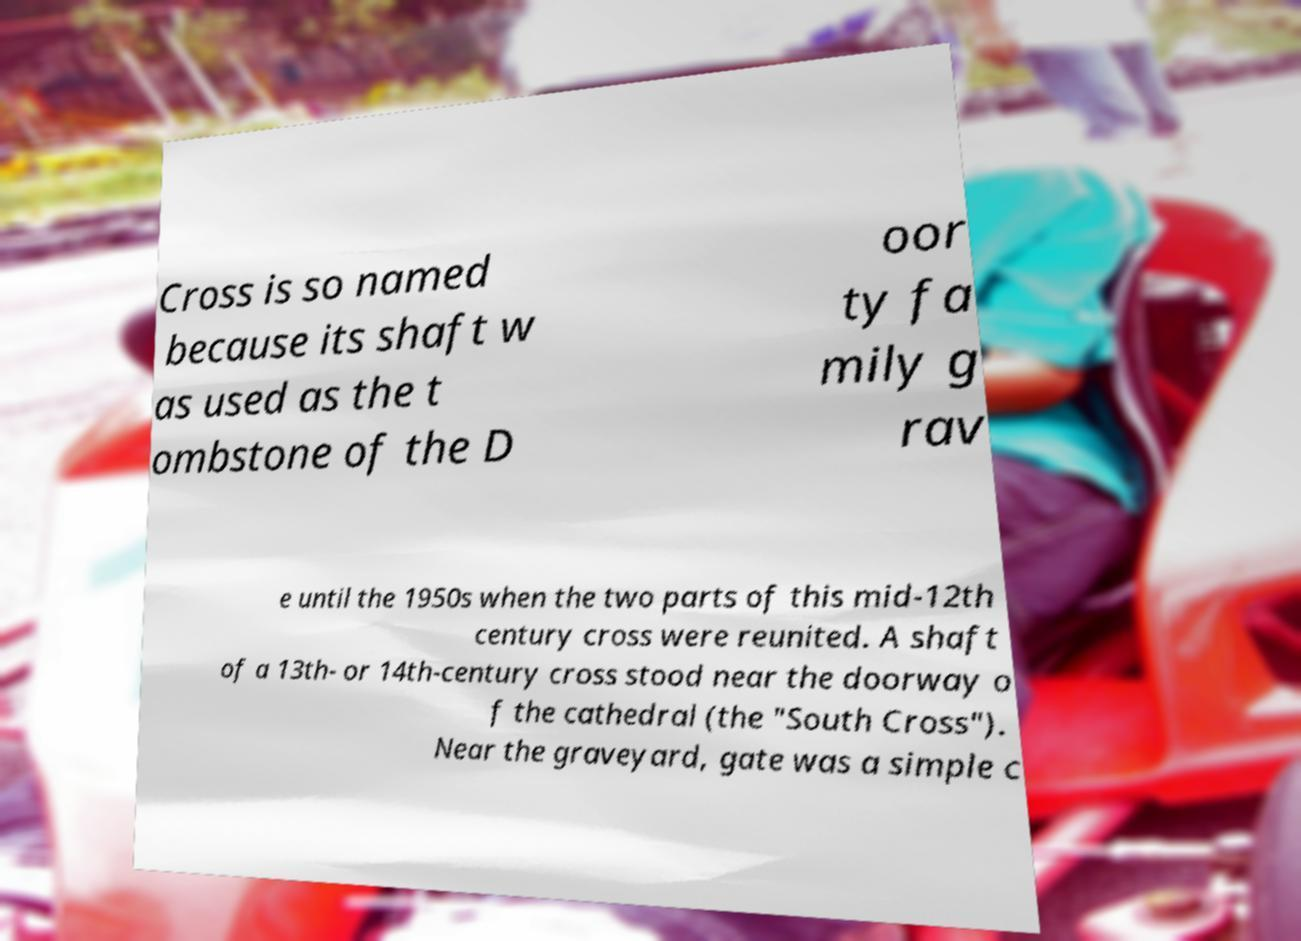Please read and relay the text visible in this image. What does it say? Cross is so named because its shaft w as used as the t ombstone of the D oor ty fa mily g rav e until the 1950s when the two parts of this mid-12th century cross were reunited. A shaft of a 13th- or 14th-century cross stood near the doorway o f the cathedral (the "South Cross"). Near the graveyard, gate was a simple c 